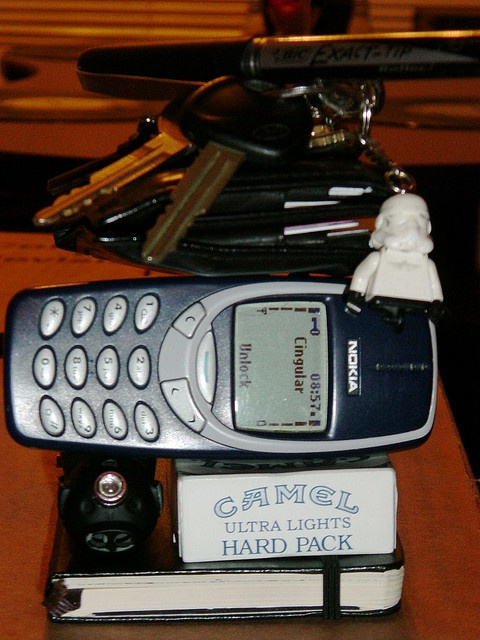Describe the objects in this image and their specific colors. I can see cell phone in maroon, darkgray, black, lightgray, and gray tones and book in maroon, lightgray, black, and darkgray tones in this image. 